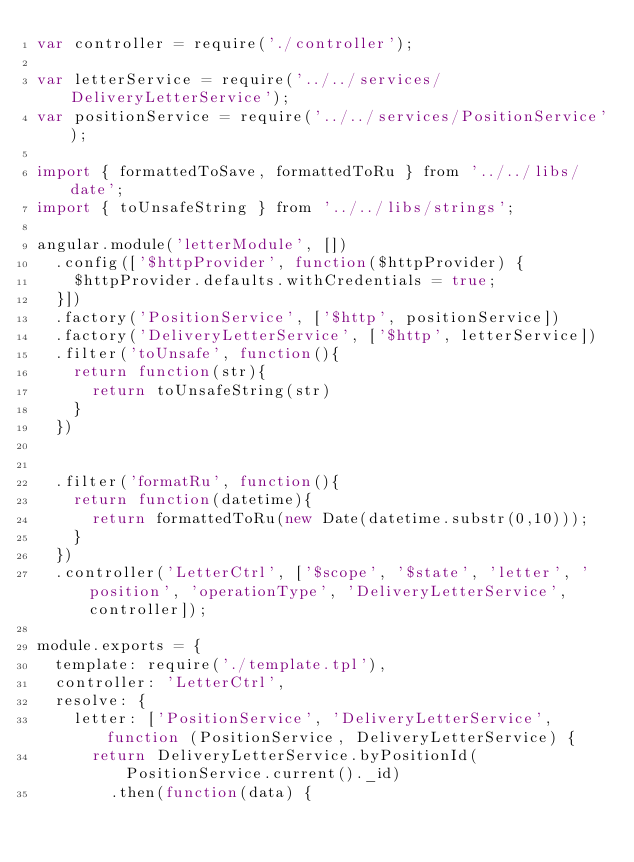<code> <loc_0><loc_0><loc_500><loc_500><_JavaScript_>var controller = require('./controller');

var letterService = require('../../services/DeliveryLetterService');
var positionService = require('../../services/PositionService');

import { formattedToSave, formattedToRu } from '../../libs/date';
import { toUnsafeString } from '../../libs/strings';

angular.module('letterModule', [])
  .config(['$httpProvider', function($httpProvider) {
    $httpProvider.defaults.withCredentials = true;
  }])
  .factory('PositionService', ['$http', positionService])
  .factory('DeliveryLetterService', ['$http', letterService])
  .filter('toUnsafe', function(){
    return function(str){
      return toUnsafeString(str)
    }
  })


  .filter('formatRu', function(){
    return function(datetime){
      return formattedToRu(new Date(datetime.substr(0,10)));
    }
  })
  .controller('LetterCtrl', ['$scope', '$state', 'letter', 'position', 'operationType', 'DeliveryLetterService', controller]);

module.exports = {
  template: require('./template.tpl'), 
  controller: 'LetterCtrl',
  resolve: {
    letter: ['PositionService', 'DeliveryLetterService', function (PositionService, DeliveryLetterService) {
  		return DeliveryLetterService.byPositionId(PositionService.current()._id)
  			.then(function(data) {</code> 